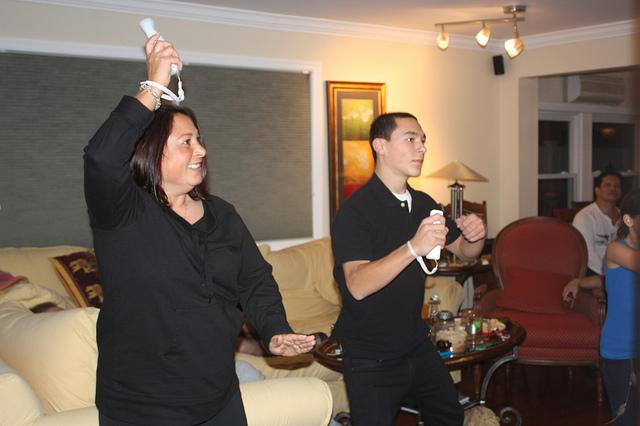The relationship between these people is most likely what? Please explain your reasoning. family. They look alike so it's probably mother and son 